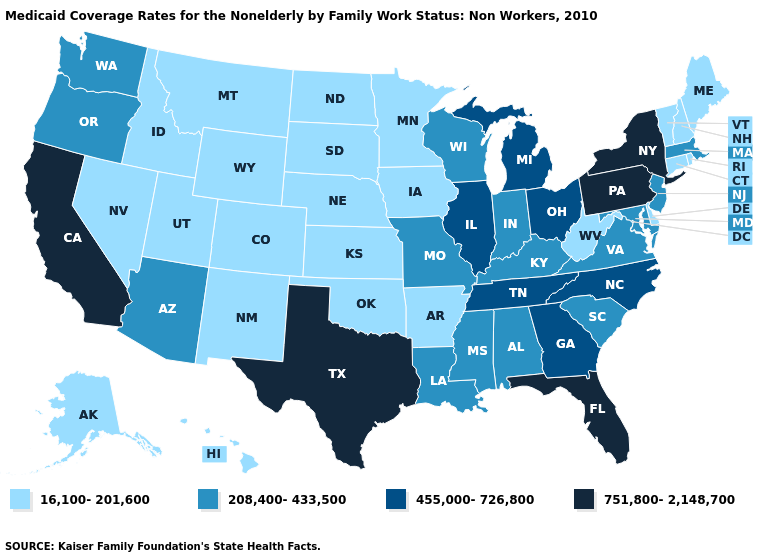Among the states that border Oklahoma , does Kansas have the lowest value?
Quick response, please. Yes. What is the highest value in states that border Tennessee?
Keep it brief. 455,000-726,800. Which states have the lowest value in the South?
Concise answer only. Arkansas, Delaware, Oklahoma, West Virginia. Name the states that have a value in the range 208,400-433,500?
Write a very short answer. Alabama, Arizona, Indiana, Kentucky, Louisiana, Maryland, Massachusetts, Mississippi, Missouri, New Jersey, Oregon, South Carolina, Virginia, Washington, Wisconsin. Which states hav the highest value in the Northeast?
Write a very short answer. New York, Pennsylvania. Does Arkansas have the highest value in the South?
Short answer required. No. What is the highest value in states that border Mississippi?
Answer briefly. 455,000-726,800. Name the states that have a value in the range 455,000-726,800?
Be succinct. Georgia, Illinois, Michigan, North Carolina, Ohio, Tennessee. Name the states that have a value in the range 455,000-726,800?
Be succinct. Georgia, Illinois, Michigan, North Carolina, Ohio, Tennessee. What is the highest value in states that border Texas?
Write a very short answer. 208,400-433,500. How many symbols are there in the legend?
Answer briefly. 4. What is the value of Kansas?
Concise answer only. 16,100-201,600. Name the states that have a value in the range 455,000-726,800?
Short answer required. Georgia, Illinois, Michigan, North Carolina, Ohio, Tennessee. What is the value of Florida?
Give a very brief answer. 751,800-2,148,700. 